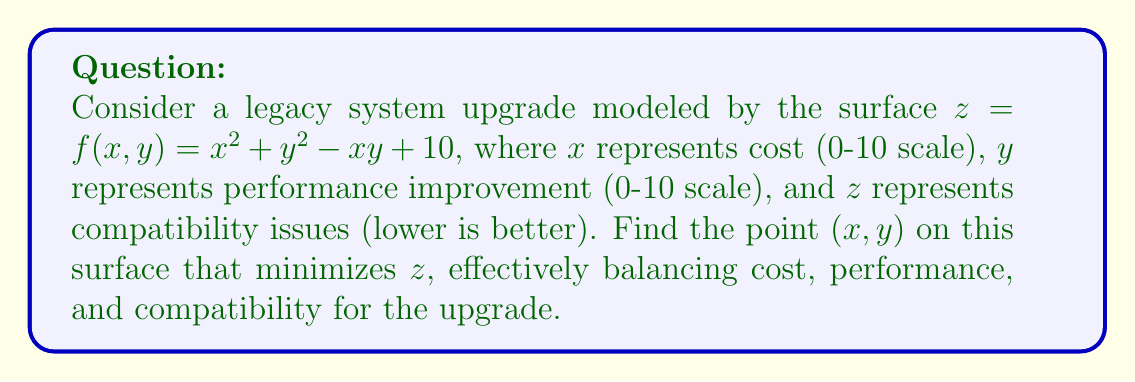Can you solve this math problem? To find the optimal point, we need to minimize the function $f(x, y) = x^2 + y^2 - xy + 10$. This involves finding the critical points where the partial derivatives are zero.

Step 1: Calculate partial derivatives
$$\frac{\partial f}{\partial x} = 2x - y$$
$$\frac{\partial f}{\partial y} = 2y - x$$

Step 2: Set partial derivatives to zero and solve the system of equations
$$2x - y = 0$$
$$2y - x = 0$$

Step 3: Solve the system
From the first equation: $y = 2x$
Substituting into the second equation:
$$2(2x) - x = 0$$
$$4x - x = 0$$
$$3x = 0$$
$$x = 0$$

And consequently, $y = 2x = 0$

Step 4: Verify it's a minimum
Calculate the Hessian matrix:
$$H = \begin{bmatrix} 
2 & -1 \\
-1 & 2
\end{bmatrix}$$

The determinant of $H$ is positive (3 > 0), and the upper-left entry is positive (2 > 0), confirming this critical point is a minimum.

Step 5: Calculate the z-value at the minimum point
$$z = f(0, 0) = 0^2 + 0^2 - 0\cdot0 + 10 = 10$$

Therefore, the point (0, 0, 10) on the surface represents the optimal balance of cost, performance, and compatibility for upgrading the legacy system.
Answer: (0, 0) 